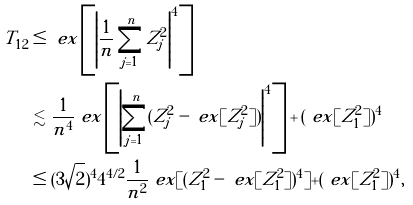<formula> <loc_0><loc_0><loc_500><loc_500>T _ { 1 2 } & \leq \ e x \left [ \left | \frac { 1 } { n } \sum _ { j = 1 } ^ { n } Z _ { j } ^ { 2 } \right | ^ { 4 } \right ] \\ & \lesssim \frac { 1 } { n ^ { 4 } } \ e x \left [ \left | \sum _ { j = 1 } ^ { n } ( Z _ { j } ^ { 2 } - \ e x [ Z _ { j } ^ { 2 } ] ) \right | ^ { 4 } \right ] + ( \ e x [ Z _ { 1 } ^ { 2 } ] ) ^ { 4 } \\ & \leq ( 3 \sqrt { 2 } ) ^ { 4 } 4 ^ { 4 / 2 } \frac { 1 } { n ^ { 2 } } \ e x [ ( Z _ { 1 } ^ { 2 } - \ e x [ Z _ { 1 } ^ { 2 } ] ) ^ { 4 } ] + ( \ e x [ Z _ { 1 } ^ { 2 } ] ) ^ { 4 } ,</formula> 